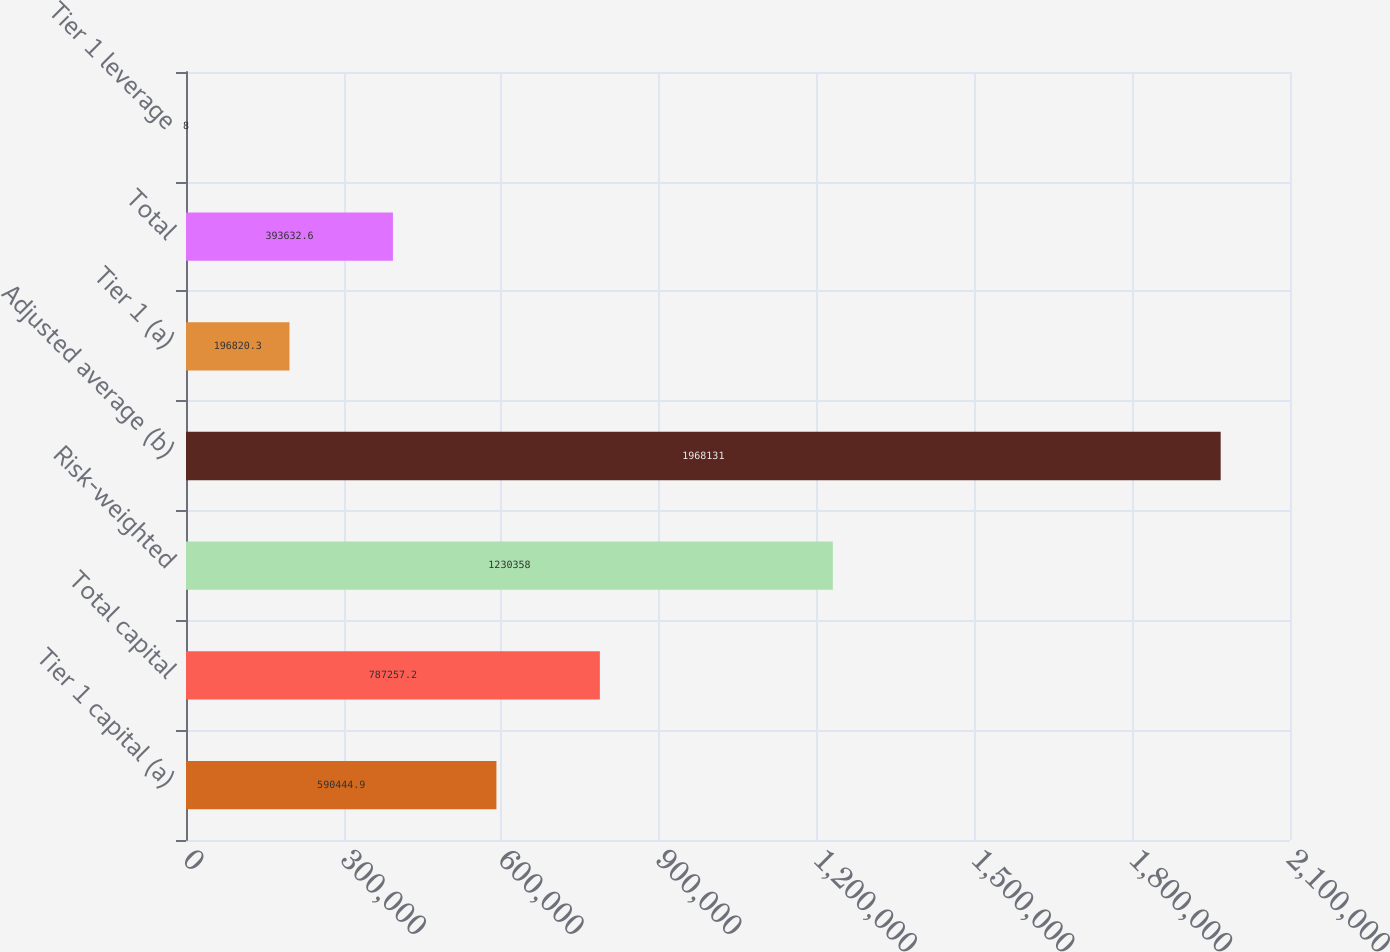<chart> <loc_0><loc_0><loc_500><loc_500><bar_chart><fcel>Tier 1 capital (a)<fcel>Total capital<fcel>Risk-weighted<fcel>Adjusted average (b)<fcel>Tier 1 (a)<fcel>Total<fcel>Tier 1 leverage<nl><fcel>590445<fcel>787257<fcel>1.23036e+06<fcel>1.96813e+06<fcel>196820<fcel>393633<fcel>8<nl></chart> 